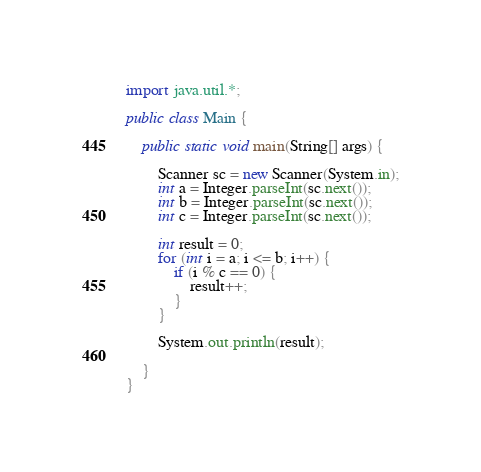Convert code to text. <code><loc_0><loc_0><loc_500><loc_500><_Java_>
import java.util.*;

public class Main {

	public static void main(String[] args) {

		Scanner sc = new Scanner(System.in);
		int a = Integer.parseInt(sc.next());
		int b = Integer.parseInt(sc.next());
		int c = Integer.parseInt(sc.next());

		int result = 0;
		for (int i = a; i <= b; i++) {
			if (i % c == 0) {
				result++;
			}
		}

		System.out.println(result);

	}
}
</code> 